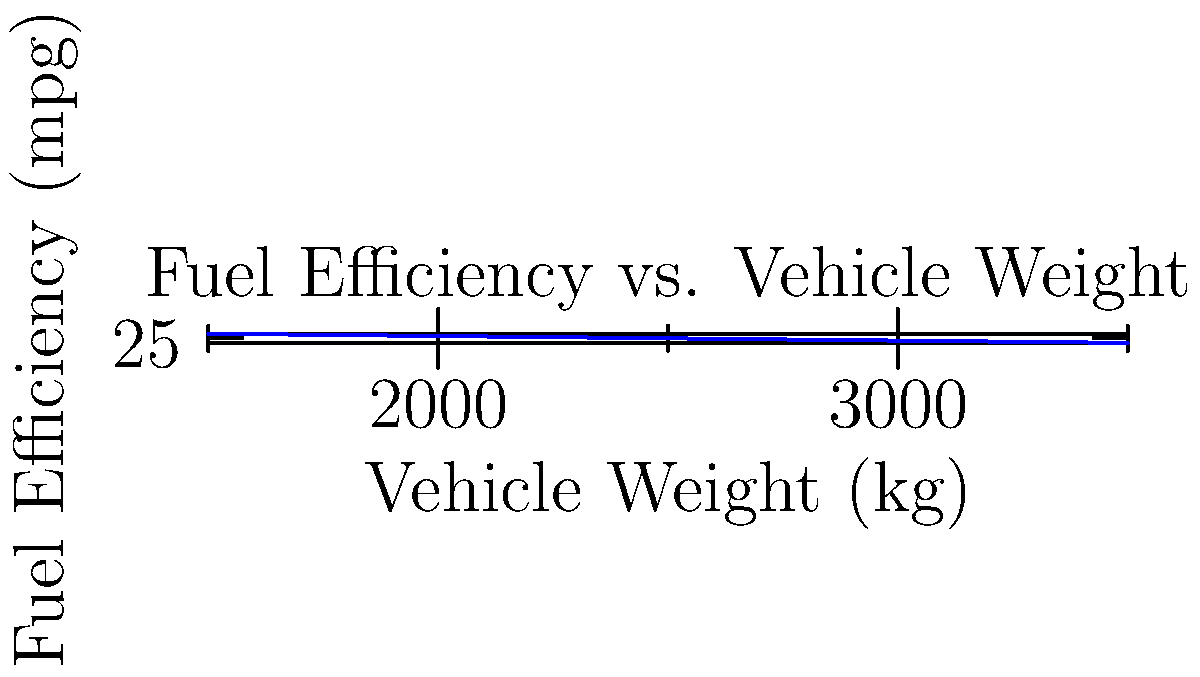Based on the graph showing the relationship between vehicle weight and fuel efficiency, what would be the estimated fuel efficiency for a car weighing 2750 kg? To estimate the fuel efficiency for a car weighing 2750 kg, we need to follow these steps:

1. Observe the trend in the graph: As vehicle weight increases, fuel efficiency decreases.

2. Identify the data points closest to 2750 kg:
   - At 2500 kg, the fuel efficiency is approximately 25 mpg
   - At 3000 kg, the fuel efficiency is approximately 20 mpg

3. Use linear interpolation to estimate the fuel efficiency at 2750 kg:
   
   Let $x_1 = 2500$, $y_1 = 25$, $x_2 = 3000$, $y_2 = 20$, and $x = 2750$

   The formula for linear interpolation is:

   $y = y_1 + \frac{(x - x_1)(y_2 - y_1)}{(x_2 - x_1)}$

4. Plug in the values:

   $y = 25 + \frac{(2750 - 2500)(20 - 25)}{(3000 - 2500)}$

   $= 25 + \frac{250 \cdot (-5)}{500}$

   $= 25 - 2.5$

   $= 22.5$

5. Round to the nearest whole number, as fuel efficiency is typically reported in whole mpg.

Therefore, the estimated fuel efficiency for a car weighing 2750 kg is approximately 23 mpg.
Answer: 23 mpg 